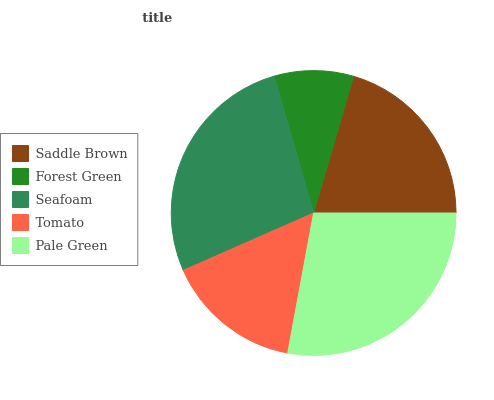Is Forest Green the minimum?
Answer yes or no. Yes. Is Pale Green the maximum?
Answer yes or no. Yes. Is Seafoam the minimum?
Answer yes or no. No. Is Seafoam the maximum?
Answer yes or no. No. Is Seafoam greater than Forest Green?
Answer yes or no. Yes. Is Forest Green less than Seafoam?
Answer yes or no. Yes. Is Forest Green greater than Seafoam?
Answer yes or no. No. Is Seafoam less than Forest Green?
Answer yes or no. No. Is Saddle Brown the high median?
Answer yes or no. Yes. Is Saddle Brown the low median?
Answer yes or no. Yes. Is Tomato the high median?
Answer yes or no. No. Is Tomato the low median?
Answer yes or no. No. 